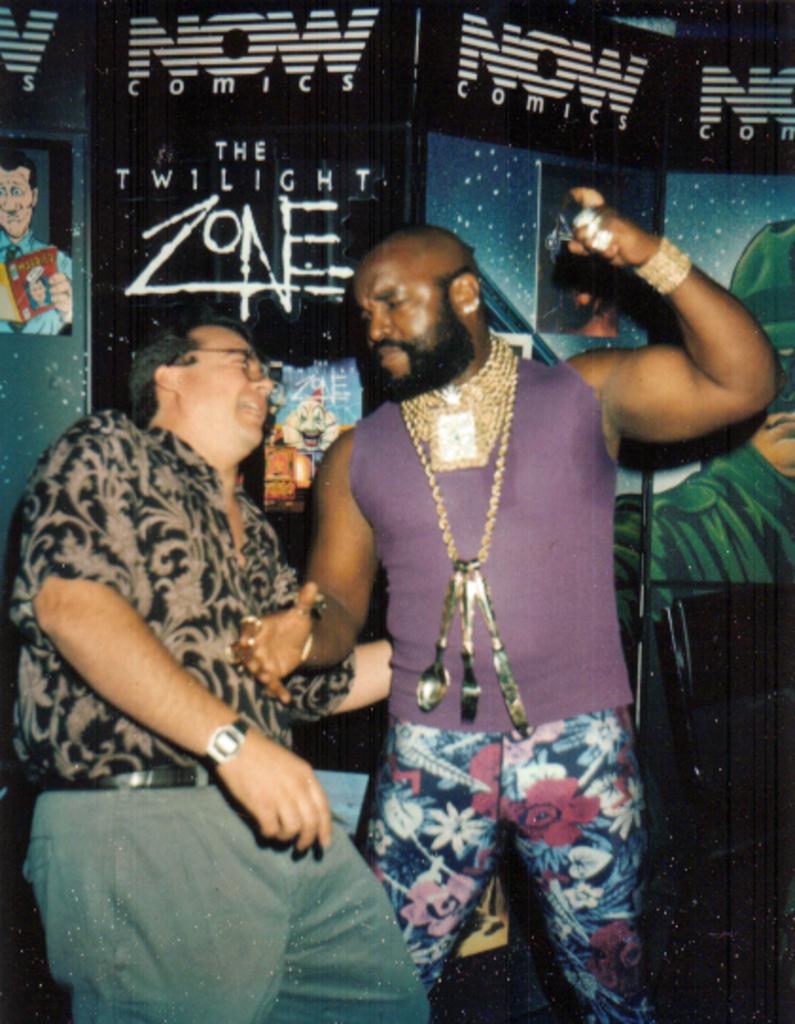In one or two sentences, can you explain what this image depicts? Here in this picture we can see two men standing over a place and the person on the right side is wearing number of chains and bracelets and earrings on him and behind them we can see posters present on the wall over there. 